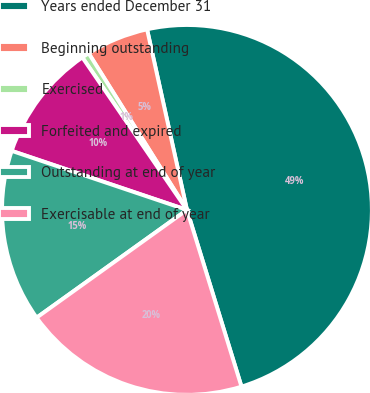Convert chart. <chart><loc_0><loc_0><loc_500><loc_500><pie_chart><fcel>Years ended December 31<fcel>Beginning outstanding<fcel>Exercised<fcel>Forfeited and expired<fcel>Outstanding at end of year<fcel>Exercisable at end of year<nl><fcel>48.7%<fcel>5.46%<fcel>0.65%<fcel>10.26%<fcel>15.07%<fcel>19.87%<nl></chart> 